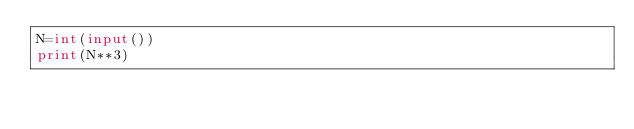Convert code to text. <code><loc_0><loc_0><loc_500><loc_500><_Python_>N=int(input())
print(N**3)</code> 